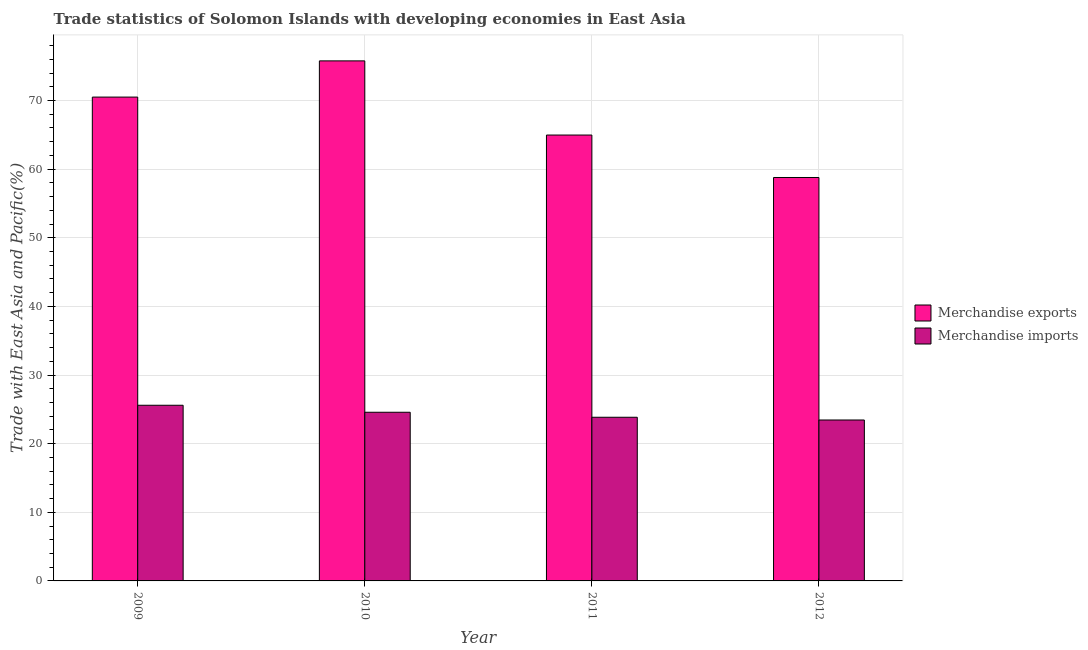How many different coloured bars are there?
Offer a terse response. 2. Are the number of bars on each tick of the X-axis equal?
Your answer should be very brief. Yes. How many bars are there on the 3rd tick from the right?
Your response must be concise. 2. In how many cases, is the number of bars for a given year not equal to the number of legend labels?
Your answer should be compact. 0. What is the merchandise exports in 2010?
Make the answer very short. 75.78. Across all years, what is the maximum merchandise exports?
Provide a short and direct response. 75.78. Across all years, what is the minimum merchandise exports?
Offer a terse response. 58.78. In which year was the merchandise imports maximum?
Offer a very short reply. 2009. What is the total merchandise imports in the graph?
Offer a terse response. 97.47. What is the difference between the merchandise imports in 2009 and that in 2010?
Your answer should be compact. 1.02. What is the difference between the merchandise exports in 2011 and the merchandise imports in 2010?
Make the answer very short. -10.81. What is the average merchandise imports per year?
Your answer should be compact. 24.37. What is the ratio of the merchandise imports in 2011 to that in 2012?
Your response must be concise. 1.02. Is the merchandise imports in 2009 less than that in 2012?
Your answer should be very brief. No. Is the difference between the merchandise imports in 2010 and 2012 greater than the difference between the merchandise exports in 2010 and 2012?
Your answer should be very brief. No. What is the difference between the highest and the second highest merchandise exports?
Your answer should be compact. 5.28. What is the difference between the highest and the lowest merchandise imports?
Ensure brevity in your answer.  2.15. In how many years, is the merchandise exports greater than the average merchandise exports taken over all years?
Ensure brevity in your answer.  2. Is the sum of the merchandise exports in 2010 and 2012 greater than the maximum merchandise imports across all years?
Provide a short and direct response. Yes. What does the 2nd bar from the left in 2011 represents?
Your response must be concise. Merchandise imports. What does the 2nd bar from the right in 2012 represents?
Offer a terse response. Merchandise exports. How many bars are there?
Provide a succinct answer. 8. Are all the bars in the graph horizontal?
Provide a short and direct response. No. How many years are there in the graph?
Provide a short and direct response. 4. Are the values on the major ticks of Y-axis written in scientific E-notation?
Offer a very short reply. No. Does the graph contain any zero values?
Ensure brevity in your answer.  No. Does the graph contain grids?
Keep it short and to the point. Yes. Where does the legend appear in the graph?
Provide a succinct answer. Center right. How are the legend labels stacked?
Provide a succinct answer. Vertical. What is the title of the graph?
Offer a terse response. Trade statistics of Solomon Islands with developing economies in East Asia. Does "Technicians" appear as one of the legend labels in the graph?
Your response must be concise. No. What is the label or title of the X-axis?
Your answer should be very brief. Year. What is the label or title of the Y-axis?
Ensure brevity in your answer.  Trade with East Asia and Pacific(%). What is the Trade with East Asia and Pacific(%) in Merchandise exports in 2009?
Keep it short and to the point. 70.5. What is the Trade with East Asia and Pacific(%) in Merchandise imports in 2009?
Offer a terse response. 25.6. What is the Trade with East Asia and Pacific(%) of Merchandise exports in 2010?
Give a very brief answer. 75.78. What is the Trade with East Asia and Pacific(%) of Merchandise imports in 2010?
Offer a very short reply. 24.58. What is the Trade with East Asia and Pacific(%) of Merchandise exports in 2011?
Ensure brevity in your answer.  64.97. What is the Trade with East Asia and Pacific(%) in Merchandise imports in 2011?
Keep it short and to the point. 23.85. What is the Trade with East Asia and Pacific(%) of Merchandise exports in 2012?
Your response must be concise. 58.78. What is the Trade with East Asia and Pacific(%) of Merchandise imports in 2012?
Ensure brevity in your answer.  23.45. Across all years, what is the maximum Trade with East Asia and Pacific(%) in Merchandise exports?
Offer a terse response. 75.78. Across all years, what is the maximum Trade with East Asia and Pacific(%) in Merchandise imports?
Your response must be concise. 25.6. Across all years, what is the minimum Trade with East Asia and Pacific(%) of Merchandise exports?
Keep it short and to the point. 58.78. Across all years, what is the minimum Trade with East Asia and Pacific(%) of Merchandise imports?
Make the answer very short. 23.45. What is the total Trade with East Asia and Pacific(%) of Merchandise exports in the graph?
Your answer should be very brief. 270.03. What is the total Trade with East Asia and Pacific(%) in Merchandise imports in the graph?
Ensure brevity in your answer.  97.47. What is the difference between the Trade with East Asia and Pacific(%) of Merchandise exports in 2009 and that in 2010?
Offer a terse response. -5.28. What is the difference between the Trade with East Asia and Pacific(%) in Merchandise imports in 2009 and that in 2010?
Your answer should be compact. 1.02. What is the difference between the Trade with East Asia and Pacific(%) of Merchandise exports in 2009 and that in 2011?
Make the answer very short. 5.53. What is the difference between the Trade with East Asia and Pacific(%) of Merchandise imports in 2009 and that in 2011?
Ensure brevity in your answer.  1.75. What is the difference between the Trade with East Asia and Pacific(%) in Merchandise exports in 2009 and that in 2012?
Offer a terse response. 11.72. What is the difference between the Trade with East Asia and Pacific(%) of Merchandise imports in 2009 and that in 2012?
Keep it short and to the point. 2.15. What is the difference between the Trade with East Asia and Pacific(%) of Merchandise exports in 2010 and that in 2011?
Ensure brevity in your answer.  10.81. What is the difference between the Trade with East Asia and Pacific(%) in Merchandise imports in 2010 and that in 2011?
Your answer should be very brief. 0.73. What is the difference between the Trade with East Asia and Pacific(%) of Merchandise exports in 2010 and that in 2012?
Your answer should be compact. 16.99. What is the difference between the Trade with East Asia and Pacific(%) in Merchandise imports in 2010 and that in 2012?
Offer a terse response. 1.13. What is the difference between the Trade with East Asia and Pacific(%) of Merchandise exports in 2011 and that in 2012?
Offer a terse response. 6.19. What is the difference between the Trade with East Asia and Pacific(%) of Merchandise imports in 2011 and that in 2012?
Ensure brevity in your answer.  0.4. What is the difference between the Trade with East Asia and Pacific(%) in Merchandise exports in 2009 and the Trade with East Asia and Pacific(%) in Merchandise imports in 2010?
Provide a short and direct response. 45.92. What is the difference between the Trade with East Asia and Pacific(%) in Merchandise exports in 2009 and the Trade with East Asia and Pacific(%) in Merchandise imports in 2011?
Your response must be concise. 46.65. What is the difference between the Trade with East Asia and Pacific(%) in Merchandise exports in 2009 and the Trade with East Asia and Pacific(%) in Merchandise imports in 2012?
Your response must be concise. 47.05. What is the difference between the Trade with East Asia and Pacific(%) in Merchandise exports in 2010 and the Trade with East Asia and Pacific(%) in Merchandise imports in 2011?
Your response must be concise. 51.93. What is the difference between the Trade with East Asia and Pacific(%) in Merchandise exports in 2010 and the Trade with East Asia and Pacific(%) in Merchandise imports in 2012?
Your answer should be compact. 52.33. What is the difference between the Trade with East Asia and Pacific(%) in Merchandise exports in 2011 and the Trade with East Asia and Pacific(%) in Merchandise imports in 2012?
Give a very brief answer. 41.52. What is the average Trade with East Asia and Pacific(%) in Merchandise exports per year?
Offer a very short reply. 67.51. What is the average Trade with East Asia and Pacific(%) in Merchandise imports per year?
Ensure brevity in your answer.  24.37. In the year 2009, what is the difference between the Trade with East Asia and Pacific(%) in Merchandise exports and Trade with East Asia and Pacific(%) in Merchandise imports?
Provide a succinct answer. 44.9. In the year 2010, what is the difference between the Trade with East Asia and Pacific(%) of Merchandise exports and Trade with East Asia and Pacific(%) of Merchandise imports?
Offer a terse response. 51.2. In the year 2011, what is the difference between the Trade with East Asia and Pacific(%) in Merchandise exports and Trade with East Asia and Pacific(%) in Merchandise imports?
Give a very brief answer. 41.12. In the year 2012, what is the difference between the Trade with East Asia and Pacific(%) of Merchandise exports and Trade with East Asia and Pacific(%) of Merchandise imports?
Your response must be concise. 35.33. What is the ratio of the Trade with East Asia and Pacific(%) of Merchandise exports in 2009 to that in 2010?
Keep it short and to the point. 0.93. What is the ratio of the Trade with East Asia and Pacific(%) of Merchandise imports in 2009 to that in 2010?
Provide a short and direct response. 1.04. What is the ratio of the Trade with East Asia and Pacific(%) of Merchandise exports in 2009 to that in 2011?
Your answer should be compact. 1.09. What is the ratio of the Trade with East Asia and Pacific(%) in Merchandise imports in 2009 to that in 2011?
Give a very brief answer. 1.07. What is the ratio of the Trade with East Asia and Pacific(%) of Merchandise exports in 2009 to that in 2012?
Provide a short and direct response. 1.2. What is the ratio of the Trade with East Asia and Pacific(%) in Merchandise imports in 2009 to that in 2012?
Your response must be concise. 1.09. What is the ratio of the Trade with East Asia and Pacific(%) in Merchandise exports in 2010 to that in 2011?
Provide a succinct answer. 1.17. What is the ratio of the Trade with East Asia and Pacific(%) of Merchandise imports in 2010 to that in 2011?
Ensure brevity in your answer.  1.03. What is the ratio of the Trade with East Asia and Pacific(%) in Merchandise exports in 2010 to that in 2012?
Provide a succinct answer. 1.29. What is the ratio of the Trade with East Asia and Pacific(%) in Merchandise imports in 2010 to that in 2012?
Provide a short and direct response. 1.05. What is the ratio of the Trade with East Asia and Pacific(%) of Merchandise exports in 2011 to that in 2012?
Provide a succinct answer. 1.11. What is the difference between the highest and the second highest Trade with East Asia and Pacific(%) in Merchandise exports?
Offer a very short reply. 5.28. What is the difference between the highest and the second highest Trade with East Asia and Pacific(%) of Merchandise imports?
Your answer should be compact. 1.02. What is the difference between the highest and the lowest Trade with East Asia and Pacific(%) of Merchandise exports?
Make the answer very short. 16.99. What is the difference between the highest and the lowest Trade with East Asia and Pacific(%) in Merchandise imports?
Give a very brief answer. 2.15. 